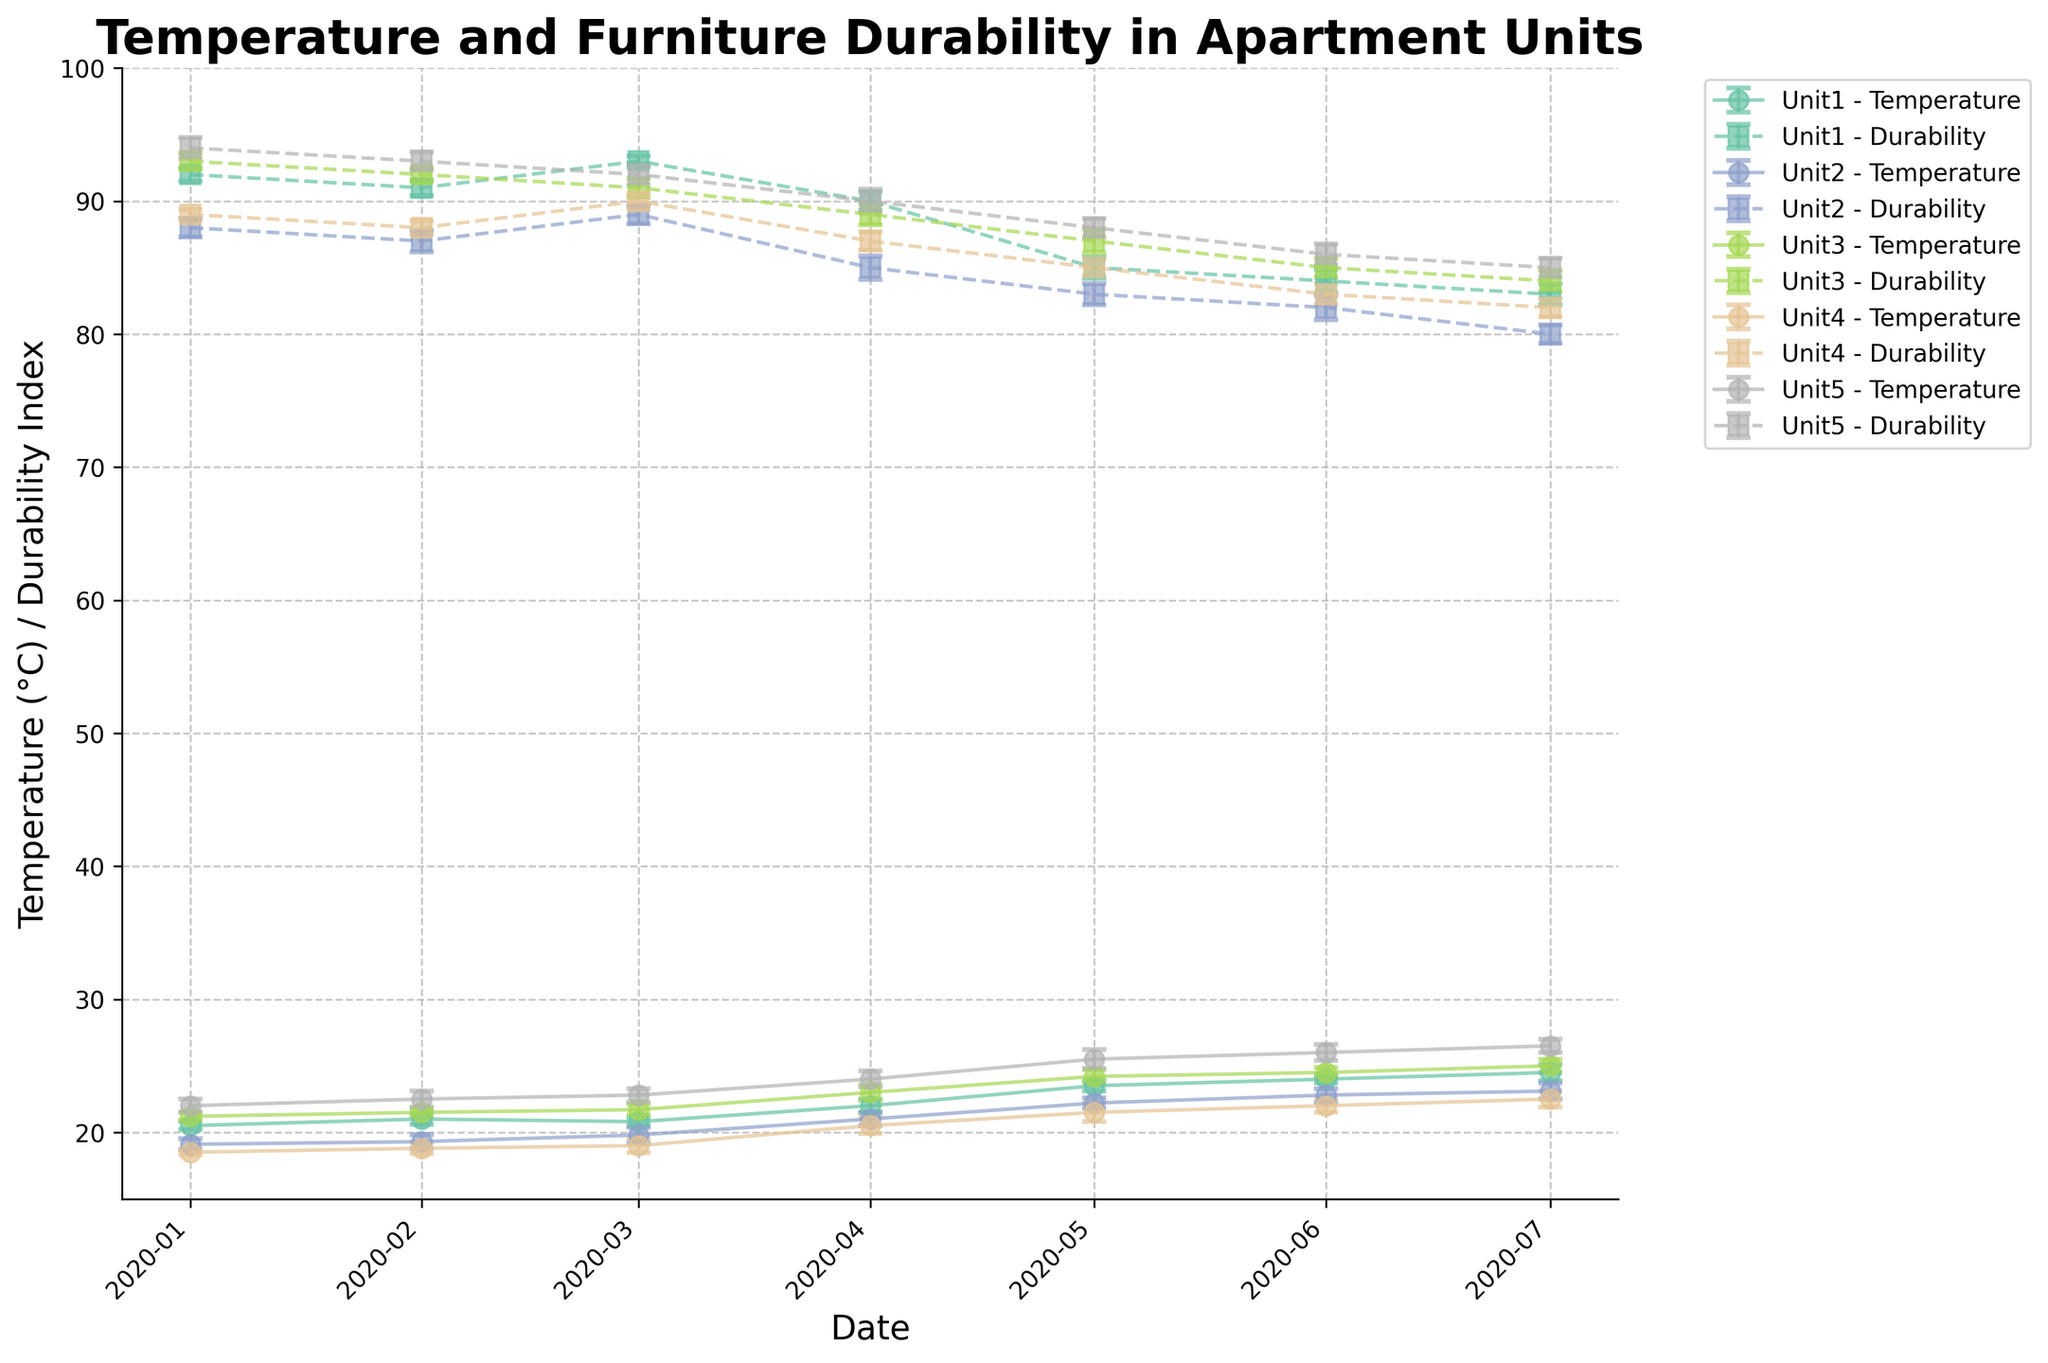What is the title of the figure? The title of the figure is usually displayed at the top center of the plot. In this case, it clearly states the main topic of the plot.
Answer: Temperature and Furniture Durability in Apartment Units How many units are represented in the figure? The figure shows multiple lines and the legend provides the labels for each line, indicating the number of unique units presented.
Answer: Five units During which month did Unit 2 have the lowest average temperature? By looking at the plot for the line corresponding to Unit 2 (as indicated by the legend) and the x-axis for "Date", we can identify the month where the temperature line is at its lowest point.
Answer: January 2020 Which unit showed the highest average temperature in June 2020? Observing the lines at the point representing June 2020 on the x-axis, we can compare the peak of each line to find the highest one for that month.
Answer: Unit 5 What is the trend in furniture durability for Unit 1 from January 2020 to July 2020? Looking at the dashed lines corresponding to Unit 1 from the legend and observing their slope from January to July 2020 on the x-axis, we can describe the overall direction.
Answer: It is decreasing Which unit had the smallest error in average temperature measurements throughout the observation period? Comparing the error bars for the average temperature across all units and periods, we identify the unit with generally the shortest error bars.
Answer: Unit 1 How does the temperature fluctuation in Unit 3 from January to July 2020 compare to its furniture durability over the same period? Observing the solid and dashed lines for Unit 3, we compare the relative slopes and variations of both lines from January to July 2020.
Answer: Both temperature and durability show an increasing trend initially, but durability decrease in July while temperature continues to rise What is the general relationship between temperature and furniture durability across all units? By examining the slopes and general trends of both the temperature and durability lines, any correlation patterns can be identified.
Answer: Higher temperatures generally correlate with lower durability If the goal is to maintain higher furniture durability, which unit appears to be the best maintained across the shown periods? Comparing the durability indices (dashed lines) across all units, the unit with the most consistently high durability can be determined.
Answer: Unit 5 Among the units, which had the greatest decrease in furniture durability from April 2020 to July 2020? By finding the largest negative change in the dashed lines between April and July 2020 for each unit, we can determine which unit experienced the greatest decrease.
Answer: Unit 2 